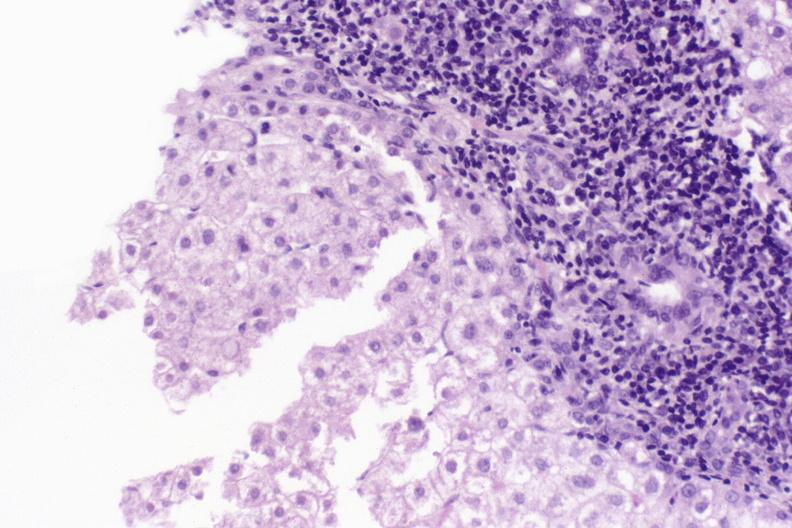s angiogram present?
Answer the question using a single word or phrase. No 